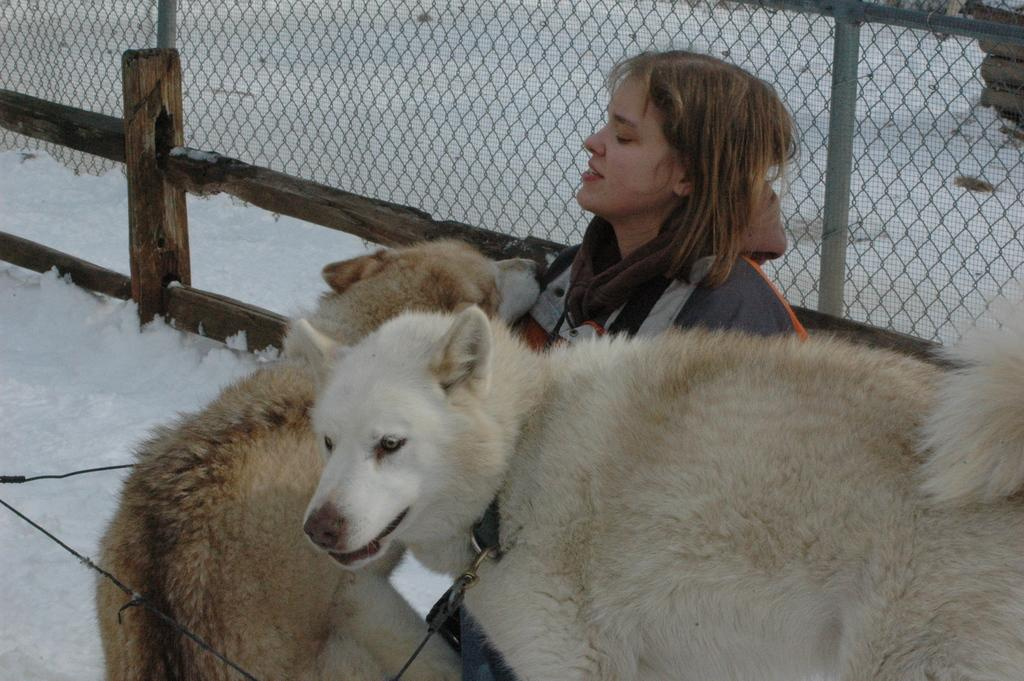What animals can be seen in the foreground of the image? There are two dogs in the foreground of the image. What is the woman in the foreground doing? The woman is sitting on the snow surface in the foreground. What type of clothing is the woman wearing? The woman is wearing an overcoat. What can be seen in the background of the image? There is a fencing in the background of the image, and the background consists of snow. What type of bell can be heard ringing in the image? There is no bell present or ringing in the image. Can you see any skates on the snow surface in the image? There are no skates visible in the image. 